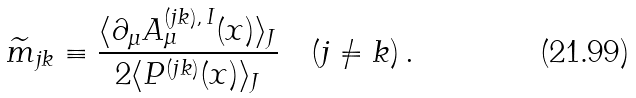Convert formula to latex. <formula><loc_0><loc_0><loc_500><loc_500>\widetilde { m } _ { j k } \equiv \frac { \langle \partial _ { \mu } A ^ { ( j k ) , \, I } _ { \mu } ( x ) \rangle _ { J } } { 2 \langle P ^ { ( j k ) } ( x ) \rangle _ { J } } \quad ( j \ne k ) \, .</formula> 